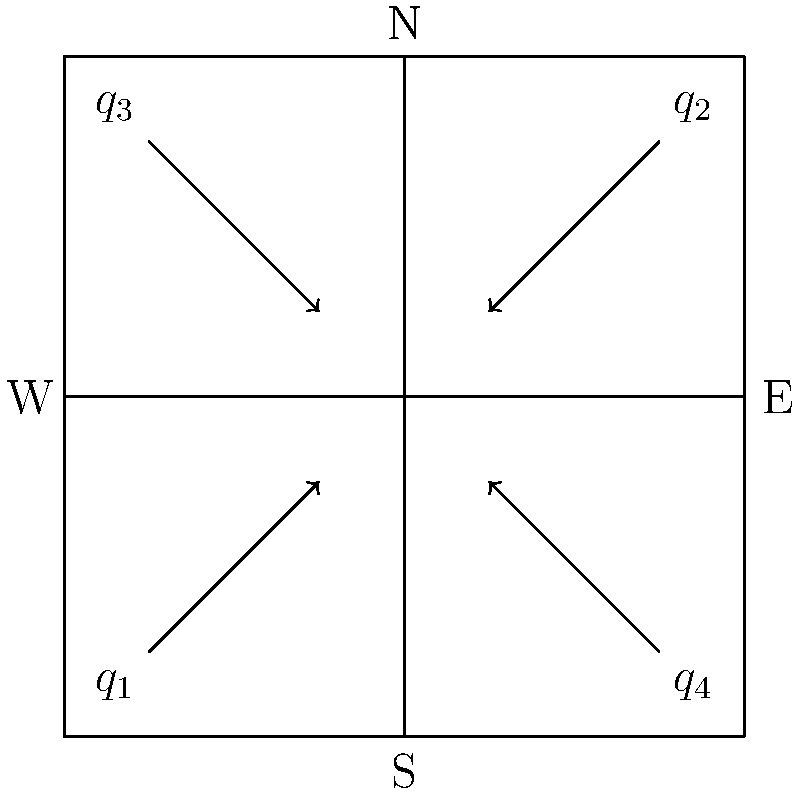At a four-way intersection, traffic flows $q_1$, $q_2$, $q_3$, and $q_4$ are observed as shown in the diagram. If the total traffic flow through the intersection is 2000 vehicles per hour and $q_1 = q_2 = 2q_3 = 2q_4$, calculate the value of $q_1$ in vehicles per hour. How might this traffic pattern remind you of the rhythmic flow in R. Kelly's "I Believe I Can Fly" from the movie Space Jam? Let's approach this step-by-step:

1) First, we need to express all flows in terms of $q_1$:
   $q_2 = q_1$
   $q_3 = \frac{1}{2}q_1$
   $q_4 = \frac{1}{2}q_1$

2) Now, we can set up an equation based on the total flow:
   $q_1 + q_2 + q_3 + q_4 = 2000$

3) Substituting the expressions from step 1:
   $q_1 + q_1 + \frac{1}{2}q_1 + \frac{1}{2}q_1 = 2000$

4) Simplify:
   $3q_1 = 2000$

5) Solve for $q_1$:
   $q_1 = \frac{2000}{3} \approx 666.67$

6) Round to the nearest whole number:
   $q_1 = 667$ vehicles per hour

This traffic pattern, with its balanced and rhythmic flow, mirrors the steady beat and uplifting progression in "I Believe I Can Fly." Just as the song builds to a crescendo, the traffic flows smoothly from all directions, creating a harmonious movement through the intersection.
Answer: 667 vehicles per hour 